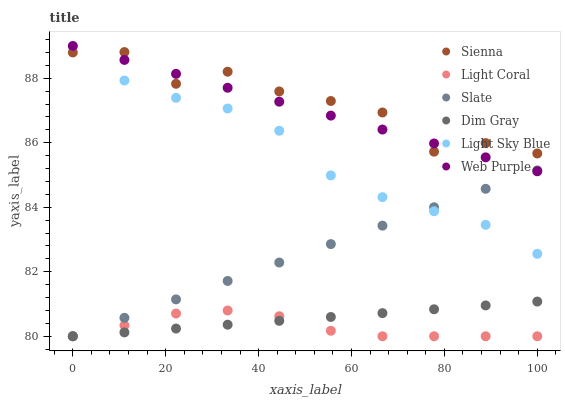Does Light Coral have the minimum area under the curve?
Answer yes or no. Yes. Does Sienna have the maximum area under the curve?
Answer yes or no. Yes. Does Dim Gray have the minimum area under the curve?
Answer yes or no. No. Does Dim Gray have the maximum area under the curve?
Answer yes or no. No. Is Dim Gray the smoothest?
Answer yes or no. Yes. Is Sienna the roughest?
Answer yes or no. Yes. Is Slate the smoothest?
Answer yes or no. No. Is Slate the roughest?
Answer yes or no. No. Does Light Coral have the lowest value?
Answer yes or no. Yes. Does Sienna have the lowest value?
Answer yes or no. No. Does Light Sky Blue have the highest value?
Answer yes or no. Yes. Does Dim Gray have the highest value?
Answer yes or no. No. Is Light Coral less than Sienna?
Answer yes or no. Yes. Is Sienna greater than Slate?
Answer yes or no. Yes. Does Light Sky Blue intersect Slate?
Answer yes or no. Yes. Is Light Sky Blue less than Slate?
Answer yes or no. No. Is Light Sky Blue greater than Slate?
Answer yes or no. No. Does Light Coral intersect Sienna?
Answer yes or no. No. 